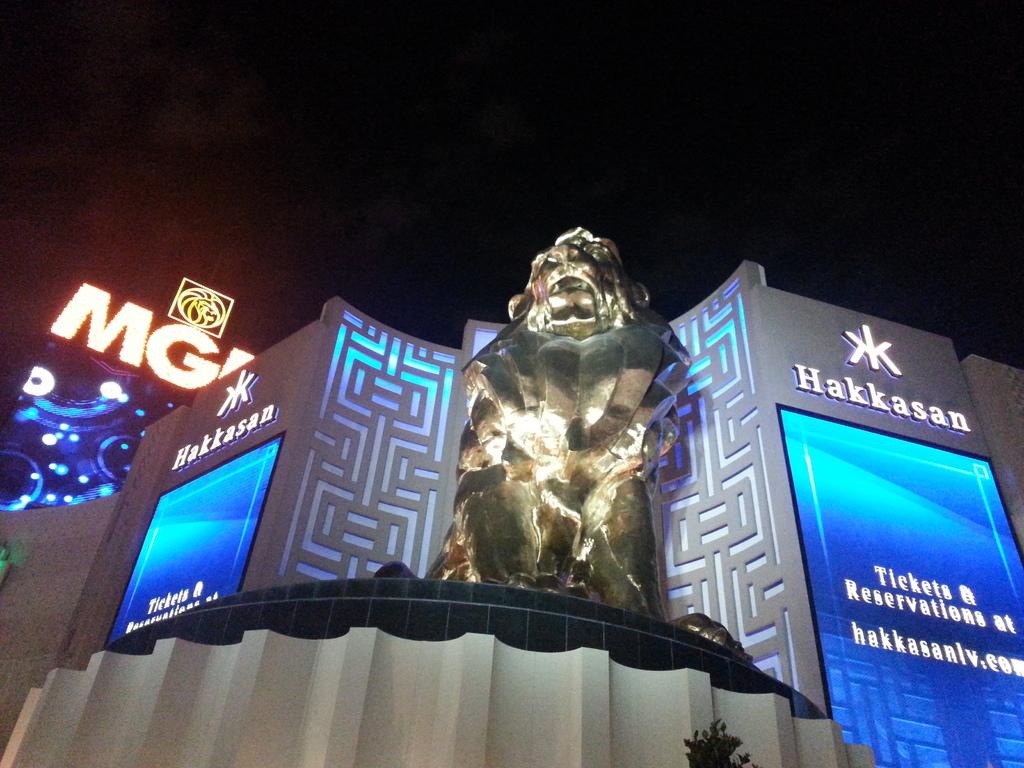What casino or hotel is pictured?
Provide a succinct answer. Hakkasan. 